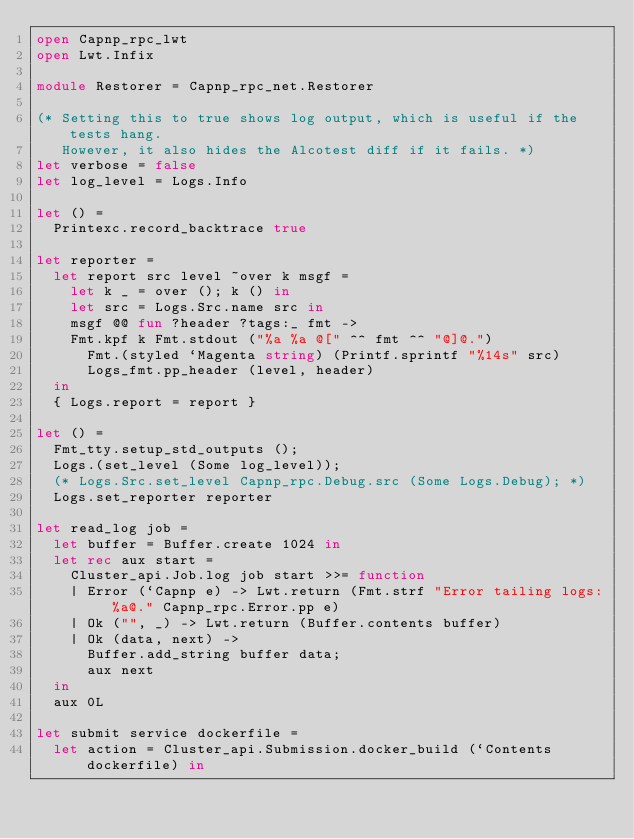Convert code to text. <code><loc_0><loc_0><loc_500><loc_500><_OCaml_>open Capnp_rpc_lwt
open Lwt.Infix

module Restorer = Capnp_rpc_net.Restorer

(* Setting this to true shows log output, which is useful if the tests hang.
   However, it also hides the Alcotest diff if it fails. *)
let verbose = false
let log_level = Logs.Info

let () =
  Printexc.record_backtrace true

let reporter =
  let report src level ~over k msgf =
    let k _ = over (); k () in
    let src = Logs.Src.name src in
    msgf @@ fun ?header ?tags:_ fmt ->
    Fmt.kpf k Fmt.stdout ("%a %a @[" ^^ fmt ^^ "@]@.")
      Fmt.(styled `Magenta string) (Printf.sprintf "%14s" src)
      Logs_fmt.pp_header (level, header)
  in
  { Logs.report = report }

let () =
  Fmt_tty.setup_std_outputs ();
  Logs.(set_level (Some log_level));
  (* Logs.Src.set_level Capnp_rpc.Debug.src (Some Logs.Debug); *)
  Logs.set_reporter reporter

let read_log job =
  let buffer = Buffer.create 1024 in
  let rec aux start =
    Cluster_api.Job.log job start >>= function
    | Error (`Capnp e) -> Lwt.return (Fmt.strf "Error tailing logs: %a@." Capnp_rpc.Error.pp e)
    | Ok ("", _) -> Lwt.return (Buffer.contents buffer)
    | Ok (data, next) ->
      Buffer.add_string buffer data;
      aux next
  in
  aux 0L

let submit service dockerfile =
  let action = Cluster_api.Submission.docker_build (`Contents dockerfile) in</code> 